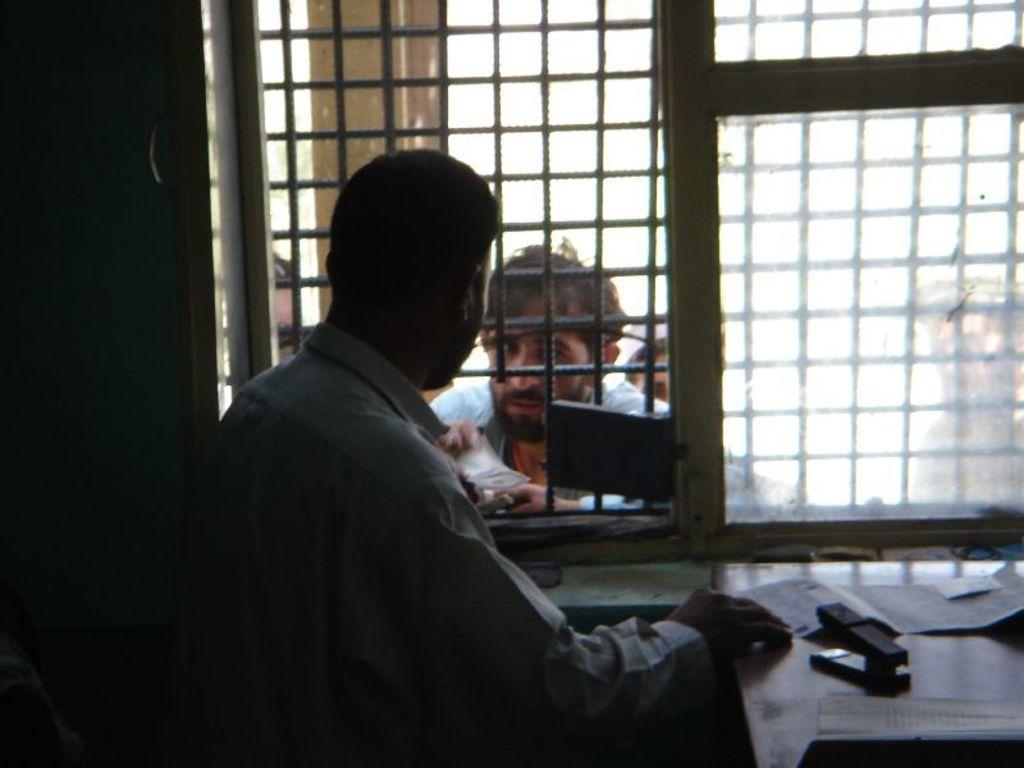In one or two sentences, can you explain what this image depicts? In this image, we can see a person standing and some are some papers and an object on the stand. In the background, there is a window and through the window we can see some other people and one of them is holding money. 